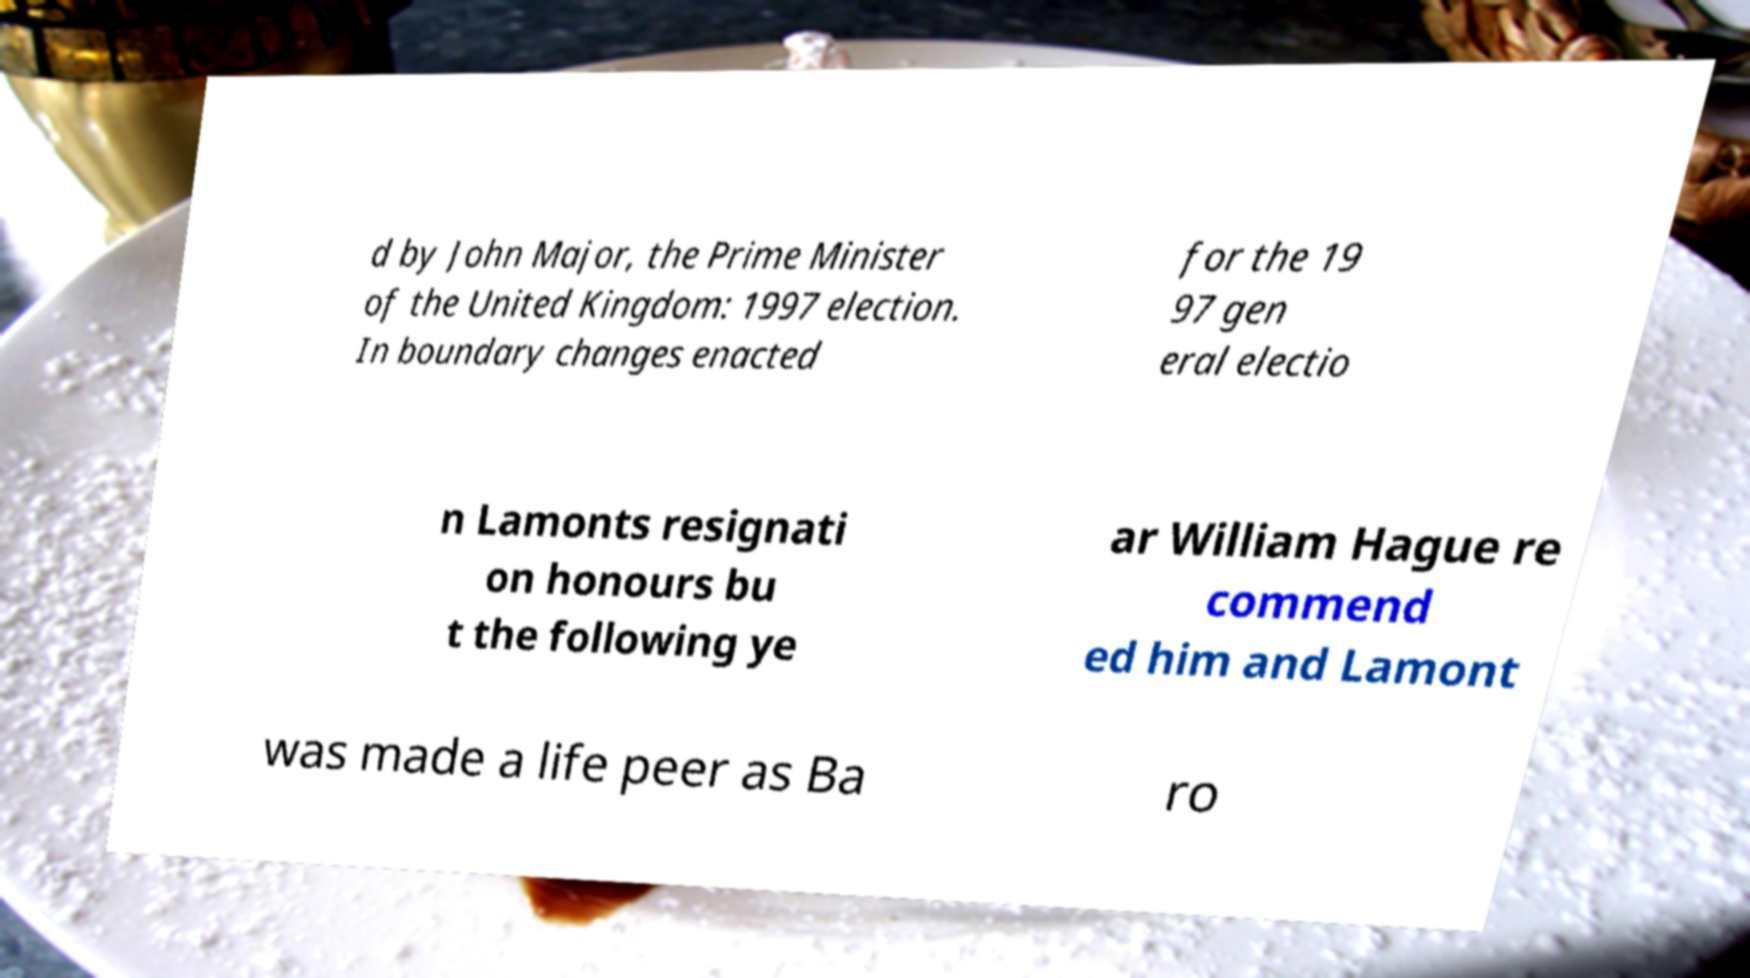For documentation purposes, I need the text within this image transcribed. Could you provide that? d by John Major, the Prime Minister of the United Kingdom: 1997 election. In boundary changes enacted for the 19 97 gen eral electio n Lamonts resignati on honours bu t the following ye ar William Hague re commend ed him and Lamont was made a life peer as Ba ro 